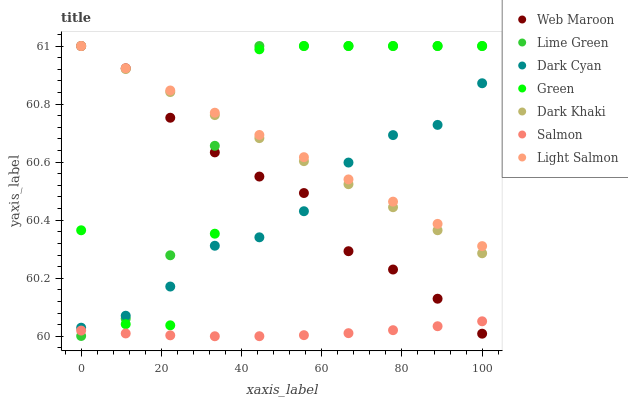Does Salmon have the minimum area under the curve?
Answer yes or no. Yes. Does Lime Green have the maximum area under the curve?
Answer yes or no. Yes. Does Web Maroon have the minimum area under the curve?
Answer yes or no. No. Does Web Maroon have the maximum area under the curve?
Answer yes or no. No. Is Dark Khaki the smoothest?
Answer yes or no. Yes. Is Green the roughest?
Answer yes or no. Yes. Is Salmon the smoothest?
Answer yes or no. No. Is Salmon the roughest?
Answer yes or no. No. Does Salmon have the lowest value?
Answer yes or no. Yes. Does Web Maroon have the lowest value?
Answer yes or no. No. Does Lime Green have the highest value?
Answer yes or no. Yes. Does Salmon have the highest value?
Answer yes or no. No. Is Salmon less than Dark Cyan?
Answer yes or no. Yes. Is Dark Cyan greater than Salmon?
Answer yes or no. Yes. Does Web Maroon intersect Green?
Answer yes or no. Yes. Is Web Maroon less than Green?
Answer yes or no. No. Is Web Maroon greater than Green?
Answer yes or no. No. Does Salmon intersect Dark Cyan?
Answer yes or no. No. 